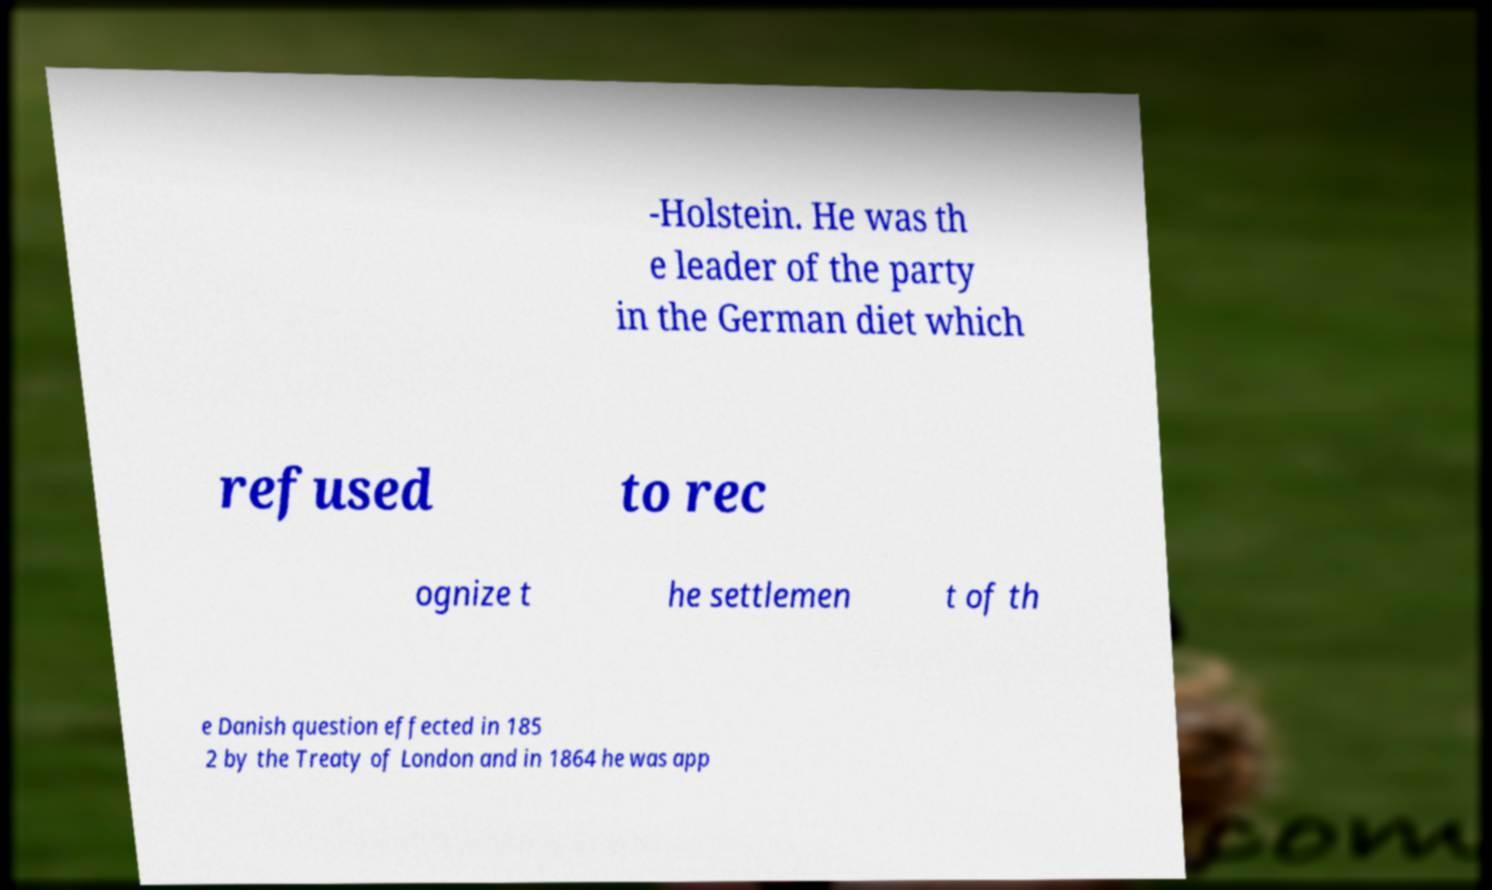Can you accurately transcribe the text from the provided image for me? -Holstein. He was th e leader of the party in the German diet which refused to rec ognize t he settlemen t of th e Danish question effected in 185 2 by the Treaty of London and in 1864 he was app 